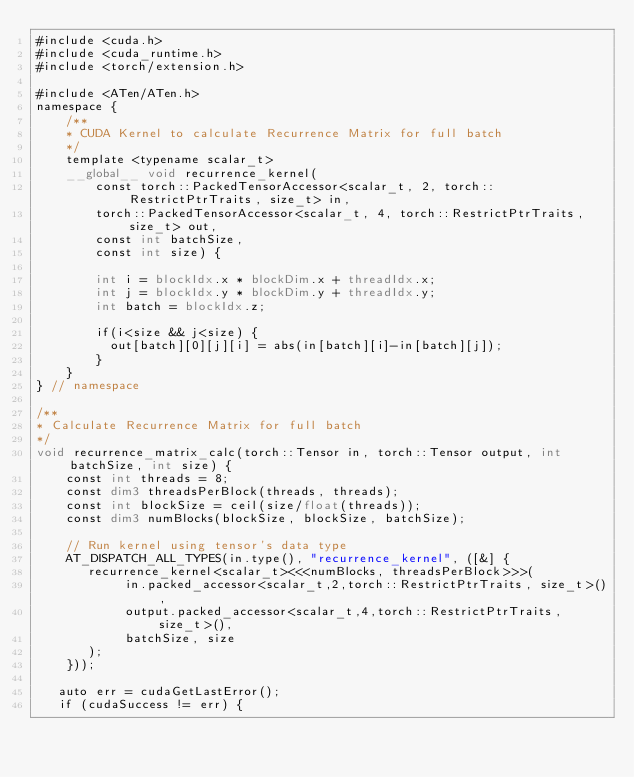Convert code to text. <code><loc_0><loc_0><loc_500><loc_500><_Cuda_>#include <cuda.h>
#include <cuda_runtime.h>
#include <torch/extension.h>

#include <ATen/ATen.h>
namespace {
    /**
    * CUDA Kernel to calculate Recurrence Matrix for full batch
    */
    template <typename scalar_t>
    __global__ void recurrence_kernel(
        const torch::PackedTensorAccessor<scalar_t, 2, torch::RestrictPtrTraits, size_t> in,
        torch::PackedTensorAccessor<scalar_t, 4, torch::RestrictPtrTraits, size_t> out,
        const int batchSize,
        const int size) {

        int i = blockIdx.x * blockDim.x + threadIdx.x;
        int j = blockIdx.y * blockDim.y + threadIdx.y;
        int batch = blockIdx.z;

        if(i<size && j<size) {
          out[batch][0][j][i] = abs(in[batch][i]-in[batch][j]);
        }
    }
} // namespace

/**
* Calculate Recurrence Matrix for full batch
*/
void recurrence_matrix_calc(torch::Tensor in, torch::Tensor output, int batchSize, int size) {
    const int threads = 8;
    const dim3 threadsPerBlock(threads, threads);
    const int blockSize = ceil(size/float(threads));
    const dim3 numBlocks(blockSize, blockSize, batchSize);

    // Run kernel using tensor's data type
    AT_DISPATCH_ALL_TYPES(in.type(), "recurrence_kernel", ([&] {
       recurrence_kernel<scalar_t><<<numBlocks, threadsPerBlock>>>(
            in.packed_accessor<scalar_t,2,torch::RestrictPtrTraits, size_t>(),
            output.packed_accessor<scalar_t,4,torch::RestrictPtrTraits, size_t>(),
            batchSize, size
       );
    }));

   auto err = cudaGetLastError();
   if (cudaSuccess != err) {</code> 